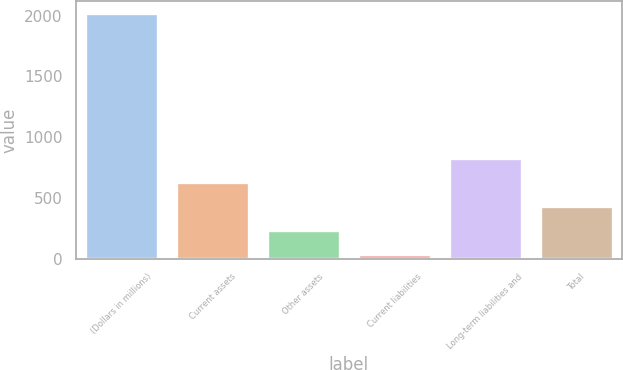Convert chart. <chart><loc_0><loc_0><loc_500><loc_500><bar_chart><fcel>(Dollars in millions)<fcel>Current assets<fcel>Other assets<fcel>Current liabilities<fcel>Long-term liabilities and<fcel>Total<nl><fcel>2018<fcel>632<fcel>236<fcel>38<fcel>830<fcel>434<nl></chart> 